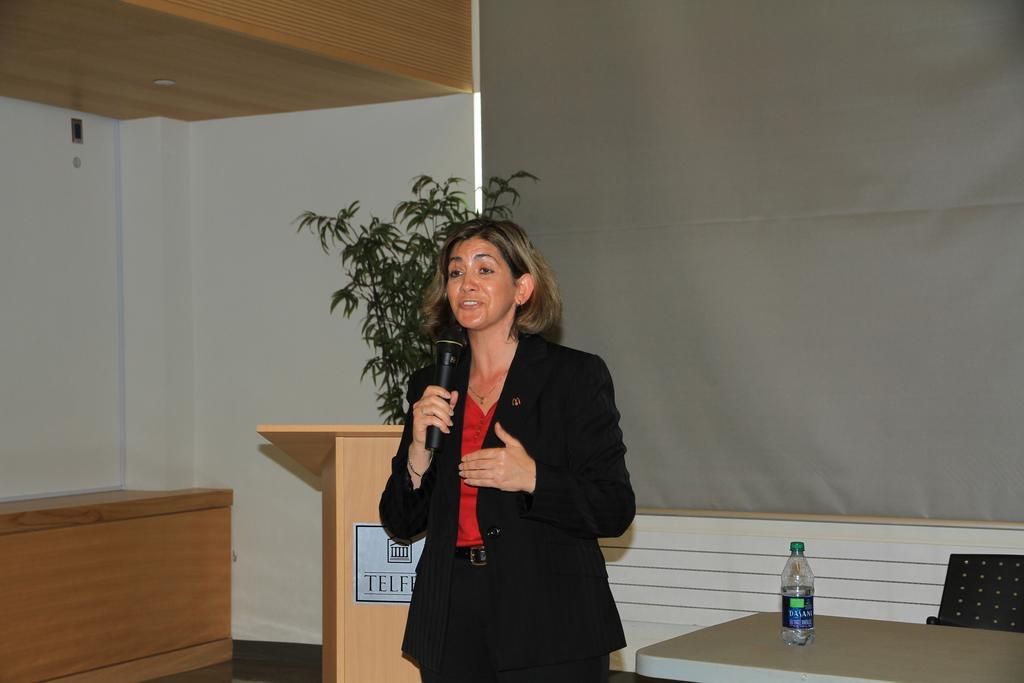Could you give a brief overview of what you see in this image? There is a woman wearing black suit is standing and speaking in front of a mic and there is a wooden stand behind her and there is a table which has a water bottle placed on it and the background is grey in color. 